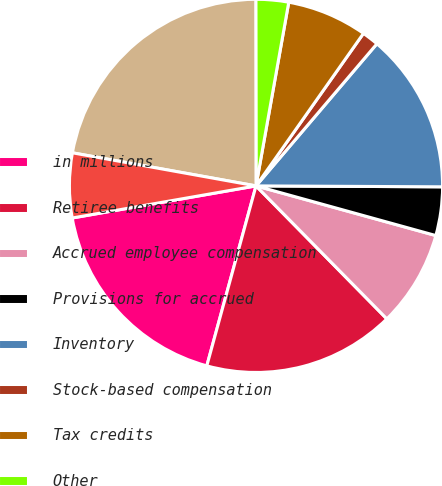Convert chart to OTSL. <chart><loc_0><loc_0><loc_500><loc_500><pie_chart><fcel>in millions<fcel>Retiree benefits<fcel>Accrued employee compensation<fcel>Provisions for accrued<fcel>Inventory<fcel>Stock-based compensation<fcel>Tax credits<fcel>Other<fcel>Gross deferred tax assets<fcel>Less valuation allowance<nl><fcel>18.0%<fcel>16.62%<fcel>8.34%<fcel>4.21%<fcel>13.86%<fcel>1.45%<fcel>6.96%<fcel>2.83%<fcel>22.14%<fcel>5.59%<nl></chart> 